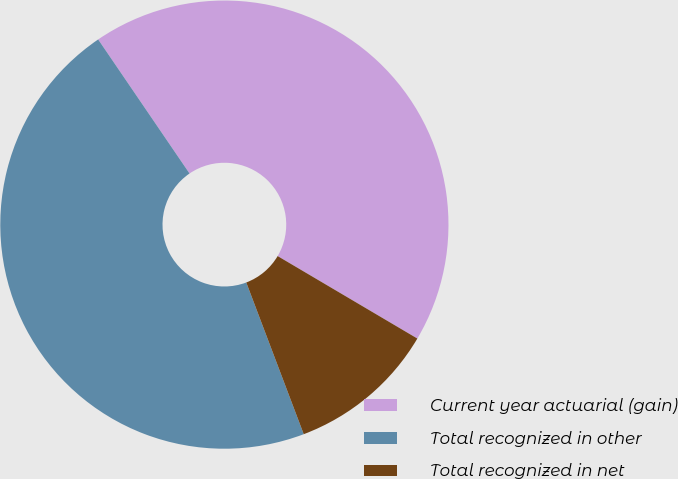<chart> <loc_0><loc_0><loc_500><loc_500><pie_chart><fcel>Current year actuarial (gain)<fcel>Total recognized in other<fcel>Total recognized in net<nl><fcel>43.01%<fcel>46.24%<fcel>10.75%<nl></chart> 